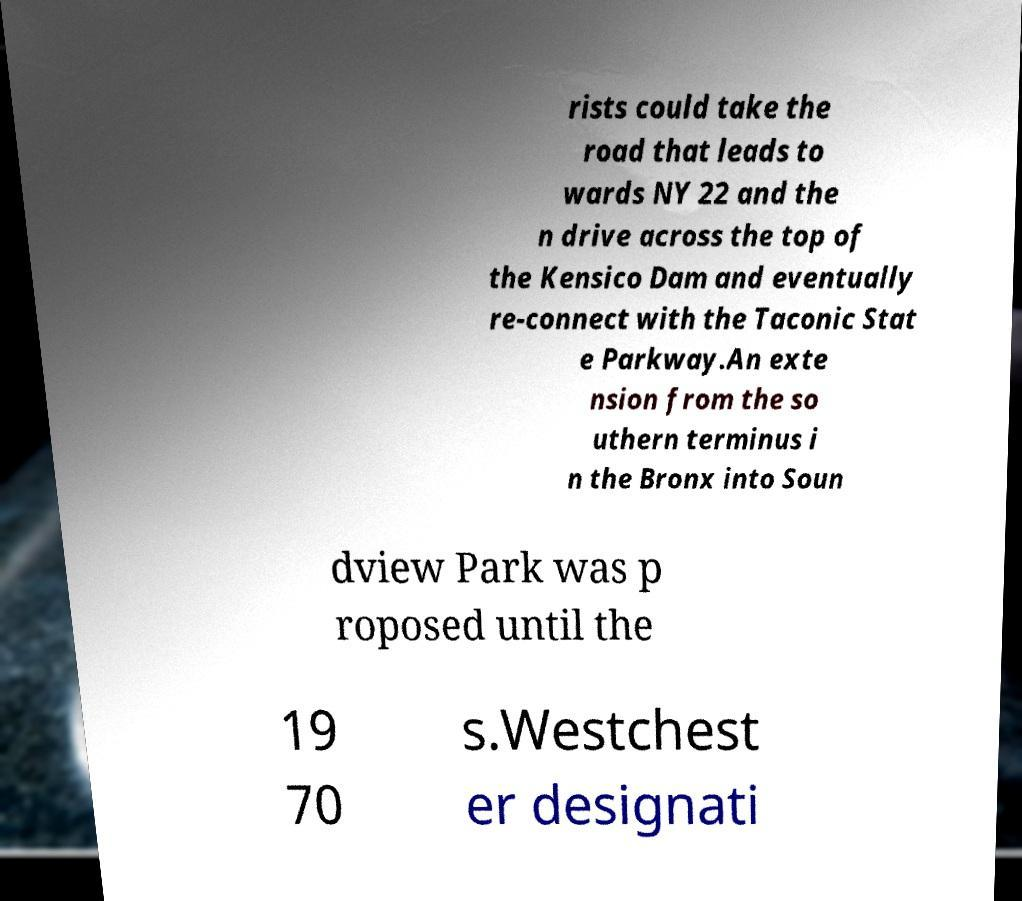Could you extract and type out the text from this image? rists could take the road that leads to wards NY 22 and the n drive across the top of the Kensico Dam and eventually re-connect with the Taconic Stat e Parkway.An exte nsion from the so uthern terminus i n the Bronx into Soun dview Park was p roposed until the 19 70 s.Westchest er designati 